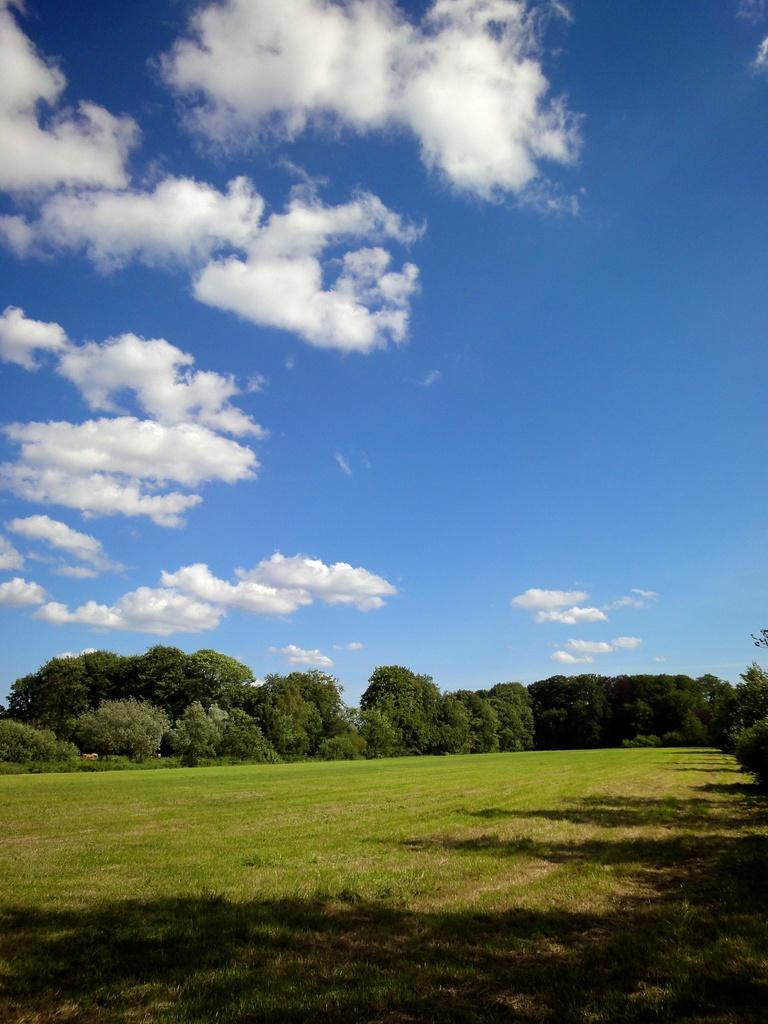What type of vegetation is present on the ground in the image? There is grass on the ground in the image. What can be seen in the background of the image? There are trees and clouds in the sky in the background of the image. Can you see any ears on the trees in the image? There are no ears present on the trees in the image, as trees do not have ears. 